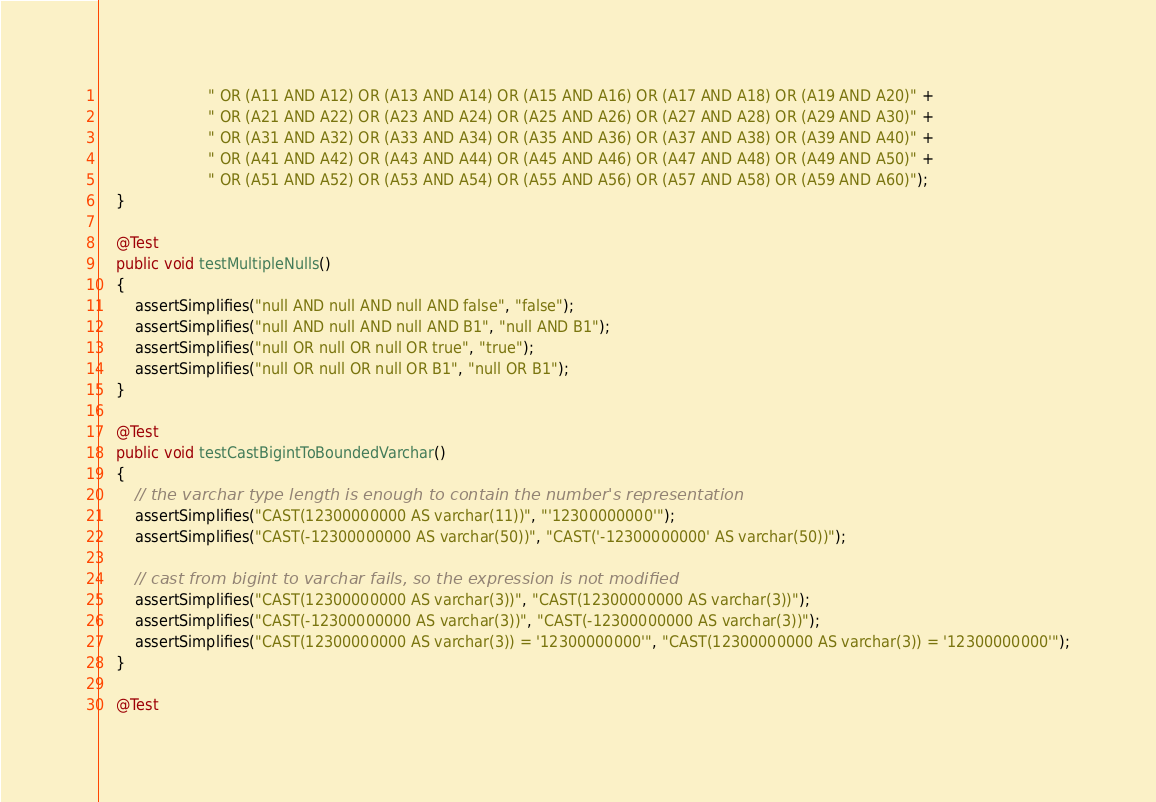Convert code to text. <code><loc_0><loc_0><loc_500><loc_500><_Java_>                        " OR (A11 AND A12) OR (A13 AND A14) OR (A15 AND A16) OR (A17 AND A18) OR (A19 AND A20)" +
                        " OR (A21 AND A22) OR (A23 AND A24) OR (A25 AND A26) OR (A27 AND A28) OR (A29 AND A30)" +
                        " OR (A31 AND A32) OR (A33 AND A34) OR (A35 AND A36) OR (A37 AND A38) OR (A39 AND A40)" +
                        " OR (A41 AND A42) OR (A43 AND A44) OR (A45 AND A46) OR (A47 AND A48) OR (A49 AND A50)" +
                        " OR (A51 AND A52) OR (A53 AND A54) OR (A55 AND A56) OR (A57 AND A58) OR (A59 AND A60)");
    }

    @Test
    public void testMultipleNulls()
    {
        assertSimplifies("null AND null AND null AND false", "false");
        assertSimplifies("null AND null AND null AND B1", "null AND B1");
        assertSimplifies("null OR null OR null OR true", "true");
        assertSimplifies("null OR null OR null OR B1", "null OR B1");
    }

    @Test
    public void testCastBigintToBoundedVarchar()
    {
        // the varchar type length is enough to contain the number's representation
        assertSimplifies("CAST(12300000000 AS varchar(11))", "'12300000000'");
        assertSimplifies("CAST(-12300000000 AS varchar(50))", "CAST('-12300000000' AS varchar(50))");

        // cast from bigint to varchar fails, so the expression is not modified
        assertSimplifies("CAST(12300000000 AS varchar(3))", "CAST(12300000000 AS varchar(3))");
        assertSimplifies("CAST(-12300000000 AS varchar(3))", "CAST(-12300000000 AS varchar(3))");
        assertSimplifies("CAST(12300000000 AS varchar(3)) = '12300000000'", "CAST(12300000000 AS varchar(3)) = '12300000000'");
    }

    @Test</code> 